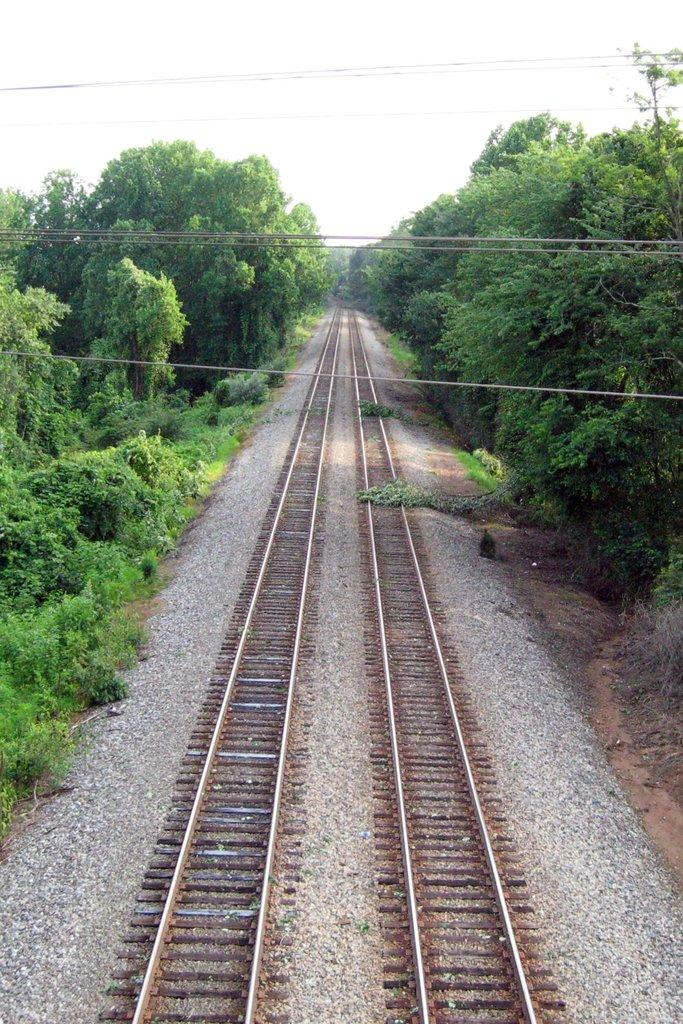What is the main subject in the center of the image? There is a railway track in the center of the image. What else can be seen in the image besides the railway track? There are wires and trees on both the right and left sides of the image. What is visible at the top of the image? The sky is visible at the top of the image. What type of food is being prepared by the beast in the image? There is no beast or food preparation present in the image. How does the motion of the train affect the trees in the image? There is no train or motion of a train present in the image. 